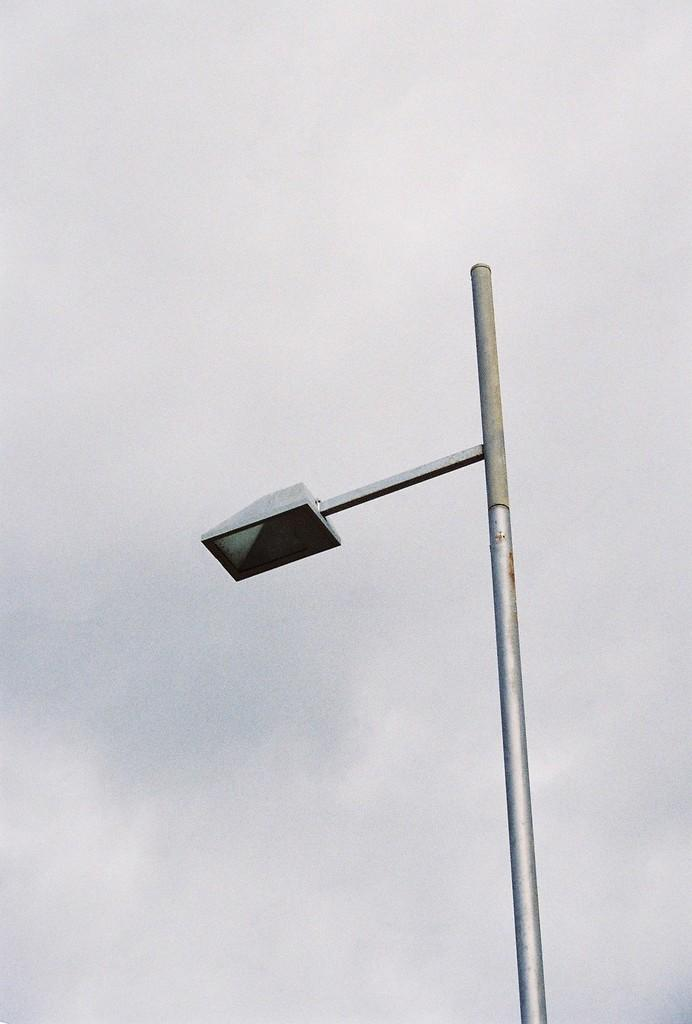What is attached to the pole in the image? There is a street light attached to the pole in the image. What can be seen in the background of the image? The sky is visible behind the pole in the image. What type of metal is the mother using to fix the nail in the image? There is no mother or nail present in the image; it only features a pole with a street light and the sky in the background. 